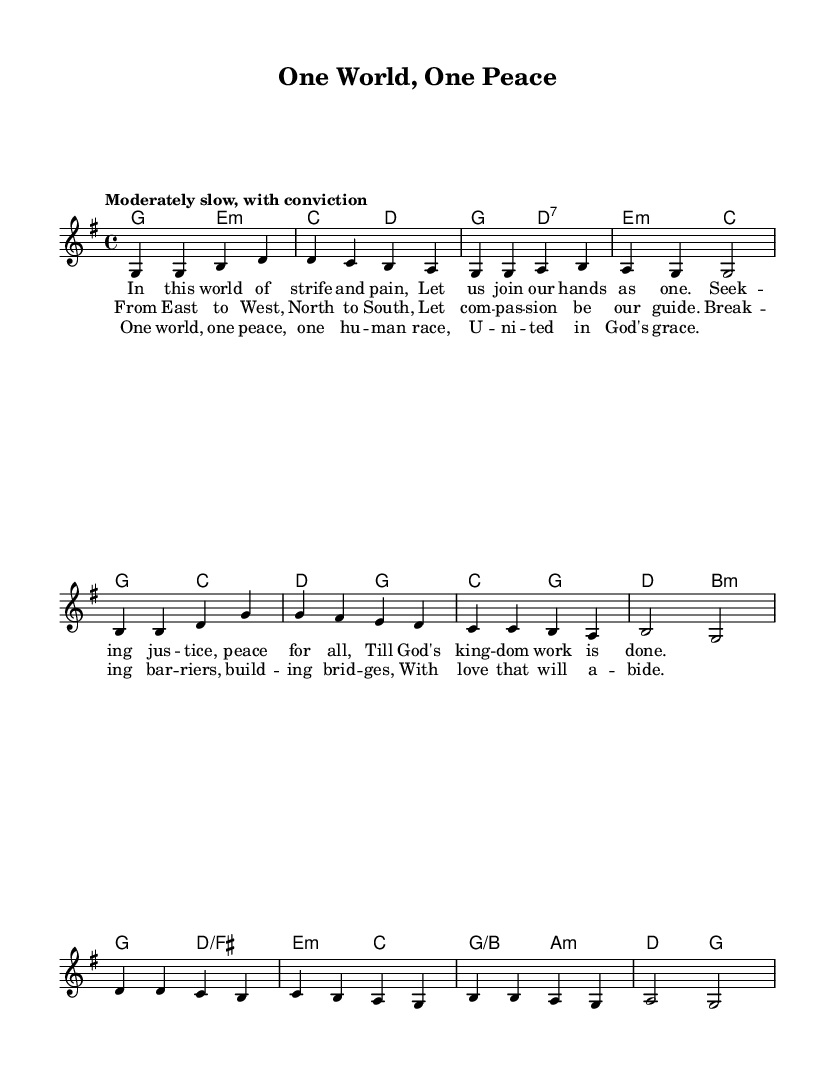What is the key signature of this music? The key signature is one sharp, indicating G major. G major has an F sharp note, which can be visually identified in the key signature section at the beginning of the staff.
Answer: G major What is the time signature of this music? The time signature is indicated as 4/4, which means there are four beats in each measure and each beat is a quarter note. This is seen in the beginning of the staff where it is explicitly noted.
Answer: 4/4 What is the tempo marking for this music? The tempo marking states "Moderately slow, with conviction," which indicates the pace at which the music should be played. This is found at the top of the music score.
Answer: Moderately slow, with conviction How many verses are there in the music? There are three verses present in the sheet music, as each set of lyrics corresponds to a different verse formatted in the score. This can be counted by identifying the distinct lyric sections under the melody.
Answer: Three What is the main theme of the lyrics in this hymn? The lyrics focus on themes of justice, compassion, and unity among humanity, highlighting the importance of social justice and international cooperation. This can be deduced from the content of the verses outlined in the lyric sections.
Answer: Justice and unity Which musical element do the lyrics emphasize as a guide for action? The lyrics emphasize "compassion" in verse two as a guiding principle, which is a key element reflecting the overall theme of the hymn. This is visible in the second verse when it explicitly mentions compassion.
Answer: Compassion What type of harmony is used in the hymn? The harmony consists of major and minor chords, including G major and E minor, which are indicated in the chord mode section of the score, showcasing the typical characteristics of gospel hymns.
Answer: Major and minor chords 